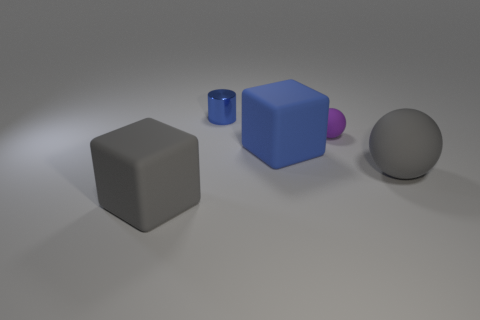Subtract all gray cubes. How many cubes are left? 1 Subtract all blocks. How many objects are left? 3 Subtract all big green matte objects. Subtract all small blue metal things. How many objects are left? 4 Add 5 big blue matte things. How many big blue matte things are left? 6 Add 3 big gray rubber objects. How many big gray rubber objects exist? 5 Add 2 large brown rubber objects. How many objects exist? 7 Subtract 0 cyan cubes. How many objects are left? 5 Subtract 1 cubes. How many cubes are left? 1 Subtract all purple spheres. Subtract all red cylinders. How many spheres are left? 1 Subtract all yellow cylinders. How many purple blocks are left? 0 